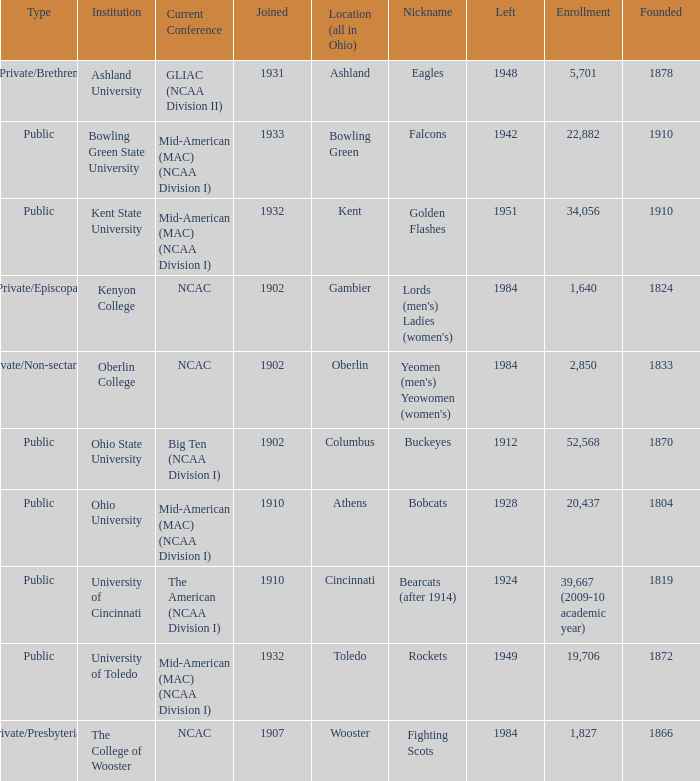What is the enrollment for Ashland University? 5701.0. 